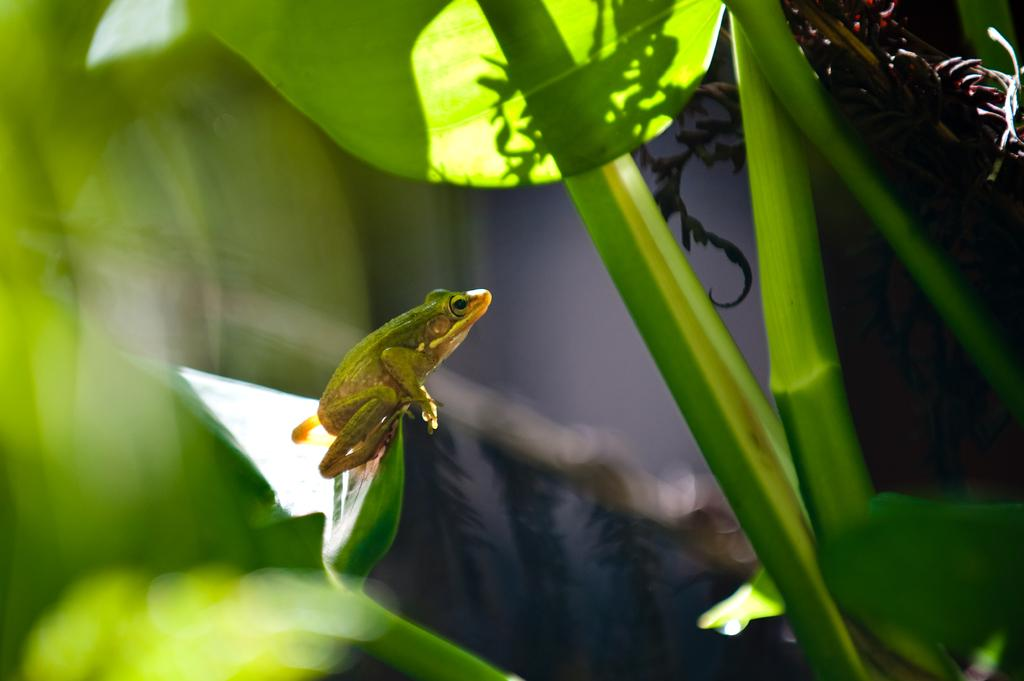What type of plant elements are present in the image? There are stems with leaves in the image. What animal can be seen in the image? There is a frog in the image. Where is the frog located in relation to the leaves? The frog is on a leaf. In which direction is the frog facing? The frog is facing towards the right side. What type of tooth is visible in the image? There is no tooth present in the image; it features a frog on a leaf. What class of animals is being taught in the image? There is no indication of a class or any teaching activity in the image. 